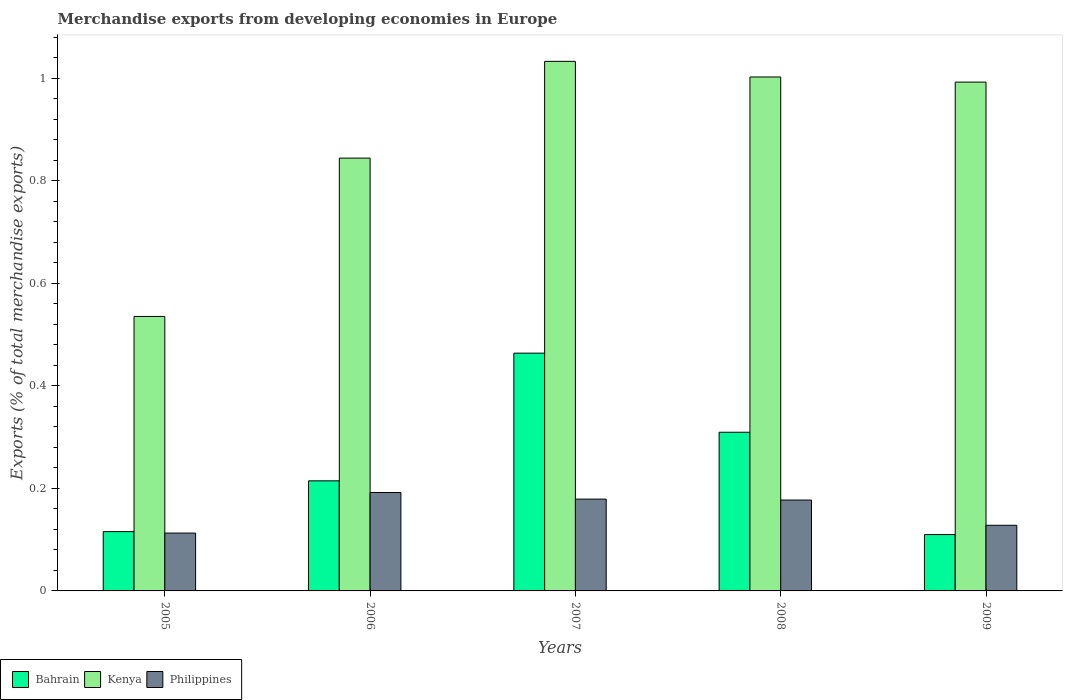How many different coloured bars are there?
Provide a short and direct response. 3. In how many cases, is the number of bars for a given year not equal to the number of legend labels?
Give a very brief answer. 0. What is the percentage of total merchandise exports in Kenya in 2008?
Keep it short and to the point. 1. Across all years, what is the maximum percentage of total merchandise exports in Bahrain?
Ensure brevity in your answer.  0.46. Across all years, what is the minimum percentage of total merchandise exports in Kenya?
Ensure brevity in your answer.  0.54. In which year was the percentage of total merchandise exports in Kenya maximum?
Provide a short and direct response. 2007. In which year was the percentage of total merchandise exports in Kenya minimum?
Ensure brevity in your answer.  2005. What is the total percentage of total merchandise exports in Bahrain in the graph?
Offer a terse response. 1.21. What is the difference between the percentage of total merchandise exports in Kenya in 2007 and that in 2009?
Your answer should be very brief. 0.04. What is the difference between the percentage of total merchandise exports in Bahrain in 2005 and the percentage of total merchandise exports in Philippines in 2009?
Give a very brief answer. -0.01. What is the average percentage of total merchandise exports in Kenya per year?
Keep it short and to the point. 0.88. In the year 2007, what is the difference between the percentage of total merchandise exports in Kenya and percentage of total merchandise exports in Bahrain?
Your response must be concise. 0.57. What is the ratio of the percentage of total merchandise exports in Bahrain in 2006 to that in 2008?
Offer a very short reply. 0.69. Is the percentage of total merchandise exports in Bahrain in 2005 less than that in 2007?
Your response must be concise. Yes. Is the difference between the percentage of total merchandise exports in Kenya in 2005 and 2009 greater than the difference between the percentage of total merchandise exports in Bahrain in 2005 and 2009?
Provide a short and direct response. No. What is the difference between the highest and the second highest percentage of total merchandise exports in Philippines?
Provide a succinct answer. 0.01. What is the difference between the highest and the lowest percentage of total merchandise exports in Kenya?
Give a very brief answer. 0.5. In how many years, is the percentage of total merchandise exports in Philippines greater than the average percentage of total merchandise exports in Philippines taken over all years?
Provide a succinct answer. 3. What does the 2nd bar from the left in 2008 represents?
Your answer should be very brief. Kenya. What does the 3rd bar from the right in 2005 represents?
Give a very brief answer. Bahrain. How many years are there in the graph?
Your response must be concise. 5. What is the difference between two consecutive major ticks on the Y-axis?
Keep it short and to the point. 0.2. Are the values on the major ticks of Y-axis written in scientific E-notation?
Your response must be concise. No. How many legend labels are there?
Make the answer very short. 3. What is the title of the graph?
Ensure brevity in your answer.  Merchandise exports from developing economies in Europe. Does "Argentina" appear as one of the legend labels in the graph?
Your response must be concise. No. What is the label or title of the X-axis?
Ensure brevity in your answer.  Years. What is the label or title of the Y-axis?
Keep it short and to the point. Exports (% of total merchandise exports). What is the Exports (% of total merchandise exports) of Bahrain in 2005?
Make the answer very short. 0.12. What is the Exports (% of total merchandise exports) of Kenya in 2005?
Your answer should be very brief. 0.54. What is the Exports (% of total merchandise exports) in Philippines in 2005?
Your answer should be compact. 0.11. What is the Exports (% of total merchandise exports) of Bahrain in 2006?
Keep it short and to the point. 0.21. What is the Exports (% of total merchandise exports) of Kenya in 2006?
Offer a terse response. 0.84. What is the Exports (% of total merchandise exports) in Philippines in 2006?
Offer a terse response. 0.19. What is the Exports (% of total merchandise exports) of Bahrain in 2007?
Your response must be concise. 0.46. What is the Exports (% of total merchandise exports) of Kenya in 2007?
Provide a short and direct response. 1.03. What is the Exports (% of total merchandise exports) in Philippines in 2007?
Ensure brevity in your answer.  0.18. What is the Exports (% of total merchandise exports) in Bahrain in 2008?
Offer a terse response. 0.31. What is the Exports (% of total merchandise exports) in Kenya in 2008?
Your answer should be very brief. 1. What is the Exports (% of total merchandise exports) in Philippines in 2008?
Give a very brief answer. 0.18. What is the Exports (% of total merchandise exports) in Bahrain in 2009?
Offer a very short reply. 0.11. What is the Exports (% of total merchandise exports) of Kenya in 2009?
Offer a very short reply. 0.99. What is the Exports (% of total merchandise exports) in Philippines in 2009?
Keep it short and to the point. 0.13. Across all years, what is the maximum Exports (% of total merchandise exports) in Bahrain?
Your answer should be very brief. 0.46. Across all years, what is the maximum Exports (% of total merchandise exports) of Kenya?
Your response must be concise. 1.03. Across all years, what is the maximum Exports (% of total merchandise exports) in Philippines?
Your response must be concise. 0.19. Across all years, what is the minimum Exports (% of total merchandise exports) of Bahrain?
Your answer should be very brief. 0.11. Across all years, what is the minimum Exports (% of total merchandise exports) in Kenya?
Offer a terse response. 0.54. Across all years, what is the minimum Exports (% of total merchandise exports) of Philippines?
Keep it short and to the point. 0.11. What is the total Exports (% of total merchandise exports) in Bahrain in the graph?
Offer a terse response. 1.21. What is the total Exports (% of total merchandise exports) of Kenya in the graph?
Keep it short and to the point. 4.41. What is the total Exports (% of total merchandise exports) of Philippines in the graph?
Give a very brief answer. 0.79. What is the difference between the Exports (% of total merchandise exports) in Bahrain in 2005 and that in 2006?
Give a very brief answer. -0.1. What is the difference between the Exports (% of total merchandise exports) of Kenya in 2005 and that in 2006?
Your response must be concise. -0.31. What is the difference between the Exports (% of total merchandise exports) of Philippines in 2005 and that in 2006?
Keep it short and to the point. -0.08. What is the difference between the Exports (% of total merchandise exports) of Bahrain in 2005 and that in 2007?
Your answer should be compact. -0.35. What is the difference between the Exports (% of total merchandise exports) in Kenya in 2005 and that in 2007?
Provide a succinct answer. -0.5. What is the difference between the Exports (% of total merchandise exports) in Philippines in 2005 and that in 2007?
Give a very brief answer. -0.07. What is the difference between the Exports (% of total merchandise exports) in Bahrain in 2005 and that in 2008?
Give a very brief answer. -0.19. What is the difference between the Exports (% of total merchandise exports) of Kenya in 2005 and that in 2008?
Make the answer very short. -0.47. What is the difference between the Exports (% of total merchandise exports) of Philippines in 2005 and that in 2008?
Give a very brief answer. -0.06. What is the difference between the Exports (% of total merchandise exports) of Bahrain in 2005 and that in 2009?
Keep it short and to the point. 0.01. What is the difference between the Exports (% of total merchandise exports) in Kenya in 2005 and that in 2009?
Provide a short and direct response. -0.46. What is the difference between the Exports (% of total merchandise exports) in Philippines in 2005 and that in 2009?
Make the answer very short. -0.02. What is the difference between the Exports (% of total merchandise exports) of Bahrain in 2006 and that in 2007?
Make the answer very short. -0.25. What is the difference between the Exports (% of total merchandise exports) in Kenya in 2006 and that in 2007?
Make the answer very short. -0.19. What is the difference between the Exports (% of total merchandise exports) of Philippines in 2006 and that in 2007?
Provide a succinct answer. 0.01. What is the difference between the Exports (% of total merchandise exports) of Bahrain in 2006 and that in 2008?
Keep it short and to the point. -0.09. What is the difference between the Exports (% of total merchandise exports) in Kenya in 2006 and that in 2008?
Offer a terse response. -0.16. What is the difference between the Exports (% of total merchandise exports) in Philippines in 2006 and that in 2008?
Give a very brief answer. 0.01. What is the difference between the Exports (% of total merchandise exports) in Bahrain in 2006 and that in 2009?
Offer a very short reply. 0.1. What is the difference between the Exports (% of total merchandise exports) of Kenya in 2006 and that in 2009?
Keep it short and to the point. -0.15. What is the difference between the Exports (% of total merchandise exports) in Philippines in 2006 and that in 2009?
Give a very brief answer. 0.06. What is the difference between the Exports (% of total merchandise exports) in Bahrain in 2007 and that in 2008?
Make the answer very short. 0.15. What is the difference between the Exports (% of total merchandise exports) of Kenya in 2007 and that in 2008?
Provide a succinct answer. 0.03. What is the difference between the Exports (% of total merchandise exports) of Philippines in 2007 and that in 2008?
Ensure brevity in your answer.  0. What is the difference between the Exports (% of total merchandise exports) of Bahrain in 2007 and that in 2009?
Provide a short and direct response. 0.35. What is the difference between the Exports (% of total merchandise exports) of Kenya in 2007 and that in 2009?
Provide a short and direct response. 0.04. What is the difference between the Exports (% of total merchandise exports) of Philippines in 2007 and that in 2009?
Make the answer very short. 0.05. What is the difference between the Exports (% of total merchandise exports) in Bahrain in 2008 and that in 2009?
Provide a short and direct response. 0.2. What is the difference between the Exports (% of total merchandise exports) in Kenya in 2008 and that in 2009?
Give a very brief answer. 0.01. What is the difference between the Exports (% of total merchandise exports) of Philippines in 2008 and that in 2009?
Your answer should be very brief. 0.05. What is the difference between the Exports (% of total merchandise exports) in Bahrain in 2005 and the Exports (% of total merchandise exports) in Kenya in 2006?
Your response must be concise. -0.73. What is the difference between the Exports (% of total merchandise exports) in Bahrain in 2005 and the Exports (% of total merchandise exports) in Philippines in 2006?
Offer a terse response. -0.08. What is the difference between the Exports (% of total merchandise exports) in Kenya in 2005 and the Exports (% of total merchandise exports) in Philippines in 2006?
Offer a very short reply. 0.34. What is the difference between the Exports (% of total merchandise exports) of Bahrain in 2005 and the Exports (% of total merchandise exports) of Kenya in 2007?
Provide a succinct answer. -0.92. What is the difference between the Exports (% of total merchandise exports) of Bahrain in 2005 and the Exports (% of total merchandise exports) of Philippines in 2007?
Provide a succinct answer. -0.06. What is the difference between the Exports (% of total merchandise exports) in Kenya in 2005 and the Exports (% of total merchandise exports) in Philippines in 2007?
Ensure brevity in your answer.  0.36. What is the difference between the Exports (% of total merchandise exports) of Bahrain in 2005 and the Exports (% of total merchandise exports) of Kenya in 2008?
Your answer should be compact. -0.89. What is the difference between the Exports (% of total merchandise exports) in Bahrain in 2005 and the Exports (% of total merchandise exports) in Philippines in 2008?
Make the answer very short. -0.06. What is the difference between the Exports (% of total merchandise exports) in Kenya in 2005 and the Exports (% of total merchandise exports) in Philippines in 2008?
Offer a very short reply. 0.36. What is the difference between the Exports (% of total merchandise exports) of Bahrain in 2005 and the Exports (% of total merchandise exports) of Kenya in 2009?
Your answer should be compact. -0.88. What is the difference between the Exports (% of total merchandise exports) of Bahrain in 2005 and the Exports (% of total merchandise exports) of Philippines in 2009?
Offer a very short reply. -0.01. What is the difference between the Exports (% of total merchandise exports) in Kenya in 2005 and the Exports (% of total merchandise exports) in Philippines in 2009?
Your answer should be compact. 0.41. What is the difference between the Exports (% of total merchandise exports) of Bahrain in 2006 and the Exports (% of total merchandise exports) of Kenya in 2007?
Offer a very short reply. -0.82. What is the difference between the Exports (% of total merchandise exports) in Bahrain in 2006 and the Exports (% of total merchandise exports) in Philippines in 2007?
Offer a very short reply. 0.04. What is the difference between the Exports (% of total merchandise exports) of Kenya in 2006 and the Exports (% of total merchandise exports) of Philippines in 2007?
Your answer should be very brief. 0.67. What is the difference between the Exports (% of total merchandise exports) of Bahrain in 2006 and the Exports (% of total merchandise exports) of Kenya in 2008?
Your answer should be very brief. -0.79. What is the difference between the Exports (% of total merchandise exports) in Bahrain in 2006 and the Exports (% of total merchandise exports) in Philippines in 2008?
Provide a short and direct response. 0.04. What is the difference between the Exports (% of total merchandise exports) in Kenya in 2006 and the Exports (% of total merchandise exports) in Philippines in 2008?
Keep it short and to the point. 0.67. What is the difference between the Exports (% of total merchandise exports) of Bahrain in 2006 and the Exports (% of total merchandise exports) of Kenya in 2009?
Your answer should be very brief. -0.78. What is the difference between the Exports (% of total merchandise exports) in Bahrain in 2006 and the Exports (% of total merchandise exports) in Philippines in 2009?
Make the answer very short. 0.09. What is the difference between the Exports (% of total merchandise exports) in Kenya in 2006 and the Exports (% of total merchandise exports) in Philippines in 2009?
Give a very brief answer. 0.72. What is the difference between the Exports (% of total merchandise exports) of Bahrain in 2007 and the Exports (% of total merchandise exports) of Kenya in 2008?
Provide a succinct answer. -0.54. What is the difference between the Exports (% of total merchandise exports) in Bahrain in 2007 and the Exports (% of total merchandise exports) in Philippines in 2008?
Make the answer very short. 0.29. What is the difference between the Exports (% of total merchandise exports) of Kenya in 2007 and the Exports (% of total merchandise exports) of Philippines in 2008?
Provide a short and direct response. 0.86. What is the difference between the Exports (% of total merchandise exports) in Bahrain in 2007 and the Exports (% of total merchandise exports) in Kenya in 2009?
Your answer should be very brief. -0.53. What is the difference between the Exports (% of total merchandise exports) of Bahrain in 2007 and the Exports (% of total merchandise exports) of Philippines in 2009?
Your answer should be compact. 0.34. What is the difference between the Exports (% of total merchandise exports) of Kenya in 2007 and the Exports (% of total merchandise exports) of Philippines in 2009?
Give a very brief answer. 0.91. What is the difference between the Exports (% of total merchandise exports) of Bahrain in 2008 and the Exports (% of total merchandise exports) of Kenya in 2009?
Your answer should be very brief. -0.68. What is the difference between the Exports (% of total merchandise exports) of Bahrain in 2008 and the Exports (% of total merchandise exports) of Philippines in 2009?
Provide a succinct answer. 0.18. What is the difference between the Exports (% of total merchandise exports) in Kenya in 2008 and the Exports (% of total merchandise exports) in Philippines in 2009?
Your answer should be compact. 0.87. What is the average Exports (% of total merchandise exports) of Bahrain per year?
Ensure brevity in your answer.  0.24. What is the average Exports (% of total merchandise exports) of Kenya per year?
Offer a very short reply. 0.88. What is the average Exports (% of total merchandise exports) of Philippines per year?
Ensure brevity in your answer.  0.16. In the year 2005, what is the difference between the Exports (% of total merchandise exports) of Bahrain and Exports (% of total merchandise exports) of Kenya?
Keep it short and to the point. -0.42. In the year 2005, what is the difference between the Exports (% of total merchandise exports) of Bahrain and Exports (% of total merchandise exports) of Philippines?
Offer a very short reply. 0. In the year 2005, what is the difference between the Exports (% of total merchandise exports) in Kenya and Exports (% of total merchandise exports) in Philippines?
Your response must be concise. 0.42. In the year 2006, what is the difference between the Exports (% of total merchandise exports) in Bahrain and Exports (% of total merchandise exports) in Kenya?
Your response must be concise. -0.63. In the year 2006, what is the difference between the Exports (% of total merchandise exports) of Bahrain and Exports (% of total merchandise exports) of Philippines?
Give a very brief answer. 0.02. In the year 2006, what is the difference between the Exports (% of total merchandise exports) in Kenya and Exports (% of total merchandise exports) in Philippines?
Offer a very short reply. 0.65. In the year 2007, what is the difference between the Exports (% of total merchandise exports) of Bahrain and Exports (% of total merchandise exports) of Kenya?
Your response must be concise. -0.57. In the year 2007, what is the difference between the Exports (% of total merchandise exports) of Bahrain and Exports (% of total merchandise exports) of Philippines?
Offer a very short reply. 0.28. In the year 2007, what is the difference between the Exports (% of total merchandise exports) in Kenya and Exports (% of total merchandise exports) in Philippines?
Your answer should be compact. 0.85. In the year 2008, what is the difference between the Exports (% of total merchandise exports) in Bahrain and Exports (% of total merchandise exports) in Kenya?
Your response must be concise. -0.69. In the year 2008, what is the difference between the Exports (% of total merchandise exports) in Bahrain and Exports (% of total merchandise exports) in Philippines?
Provide a succinct answer. 0.13. In the year 2008, what is the difference between the Exports (% of total merchandise exports) in Kenya and Exports (% of total merchandise exports) in Philippines?
Your response must be concise. 0.83. In the year 2009, what is the difference between the Exports (% of total merchandise exports) in Bahrain and Exports (% of total merchandise exports) in Kenya?
Offer a terse response. -0.88. In the year 2009, what is the difference between the Exports (% of total merchandise exports) of Bahrain and Exports (% of total merchandise exports) of Philippines?
Ensure brevity in your answer.  -0.02. In the year 2009, what is the difference between the Exports (% of total merchandise exports) of Kenya and Exports (% of total merchandise exports) of Philippines?
Your answer should be compact. 0.86. What is the ratio of the Exports (% of total merchandise exports) of Bahrain in 2005 to that in 2006?
Offer a terse response. 0.54. What is the ratio of the Exports (% of total merchandise exports) in Kenya in 2005 to that in 2006?
Your answer should be compact. 0.63. What is the ratio of the Exports (% of total merchandise exports) of Philippines in 2005 to that in 2006?
Offer a terse response. 0.59. What is the ratio of the Exports (% of total merchandise exports) of Bahrain in 2005 to that in 2007?
Ensure brevity in your answer.  0.25. What is the ratio of the Exports (% of total merchandise exports) of Kenya in 2005 to that in 2007?
Offer a very short reply. 0.52. What is the ratio of the Exports (% of total merchandise exports) of Philippines in 2005 to that in 2007?
Your answer should be very brief. 0.63. What is the ratio of the Exports (% of total merchandise exports) in Bahrain in 2005 to that in 2008?
Provide a short and direct response. 0.37. What is the ratio of the Exports (% of total merchandise exports) of Kenya in 2005 to that in 2008?
Provide a succinct answer. 0.53. What is the ratio of the Exports (% of total merchandise exports) in Philippines in 2005 to that in 2008?
Offer a very short reply. 0.64. What is the ratio of the Exports (% of total merchandise exports) in Bahrain in 2005 to that in 2009?
Provide a succinct answer. 1.05. What is the ratio of the Exports (% of total merchandise exports) in Kenya in 2005 to that in 2009?
Provide a succinct answer. 0.54. What is the ratio of the Exports (% of total merchandise exports) of Philippines in 2005 to that in 2009?
Your response must be concise. 0.88. What is the ratio of the Exports (% of total merchandise exports) in Bahrain in 2006 to that in 2007?
Give a very brief answer. 0.46. What is the ratio of the Exports (% of total merchandise exports) of Kenya in 2006 to that in 2007?
Ensure brevity in your answer.  0.82. What is the ratio of the Exports (% of total merchandise exports) in Philippines in 2006 to that in 2007?
Make the answer very short. 1.07. What is the ratio of the Exports (% of total merchandise exports) in Bahrain in 2006 to that in 2008?
Provide a succinct answer. 0.69. What is the ratio of the Exports (% of total merchandise exports) of Kenya in 2006 to that in 2008?
Your answer should be very brief. 0.84. What is the ratio of the Exports (% of total merchandise exports) in Philippines in 2006 to that in 2008?
Your answer should be very brief. 1.08. What is the ratio of the Exports (% of total merchandise exports) of Bahrain in 2006 to that in 2009?
Offer a terse response. 1.95. What is the ratio of the Exports (% of total merchandise exports) in Kenya in 2006 to that in 2009?
Provide a short and direct response. 0.85. What is the ratio of the Exports (% of total merchandise exports) in Philippines in 2006 to that in 2009?
Give a very brief answer. 1.5. What is the ratio of the Exports (% of total merchandise exports) in Bahrain in 2007 to that in 2008?
Keep it short and to the point. 1.5. What is the ratio of the Exports (% of total merchandise exports) of Kenya in 2007 to that in 2008?
Offer a very short reply. 1.03. What is the ratio of the Exports (% of total merchandise exports) in Philippines in 2007 to that in 2008?
Keep it short and to the point. 1.01. What is the ratio of the Exports (% of total merchandise exports) of Bahrain in 2007 to that in 2009?
Offer a terse response. 4.22. What is the ratio of the Exports (% of total merchandise exports) of Kenya in 2007 to that in 2009?
Your answer should be compact. 1.04. What is the ratio of the Exports (% of total merchandise exports) in Philippines in 2007 to that in 2009?
Provide a succinct answer. 1.4. What is the ratio of the Exports (% of total merchandise exports) of Bahrain in 2008 to that in 2009?
Give a very brief answer. 2.82. What is the ratio of the Exports (% of total merchandise exports) in Kenya in 2008 to that in 2009?
Keep it short and to the point. 1.01. What is the ratio of the Exports (% of total merchandise exports) of Philippines in 2008 to that in 2009?
Give a very brief answer. 1.38. What is the difference between the highest and the second highest Exports (% of total merchandise exports) of Bahrain?
Offer a very short reply. 0.15. What is the difference between the highest and the second highest Exports (% of total merchandise exports) of Kenya?
Ensure brevity in your answer.  0.03. What is the difference between the highest and the second highest Exports (% of total merchandise exports) of Philippines?
Offer a very short reply. 0.01. What is the difference between the highest and the lowest Exports (% of total merchandise exports) of Bahrain?
Your answer should be compact. 0.35. What is the difference between the highest and the lowest Exports (% of total merchandise exports) of Kenya?
Your answer should be very brief. 0.5. What is the difference between the highest and the lowest Exports (% of total merchandise exports) in Philippines?
Give a very brief answer. 0.08. 